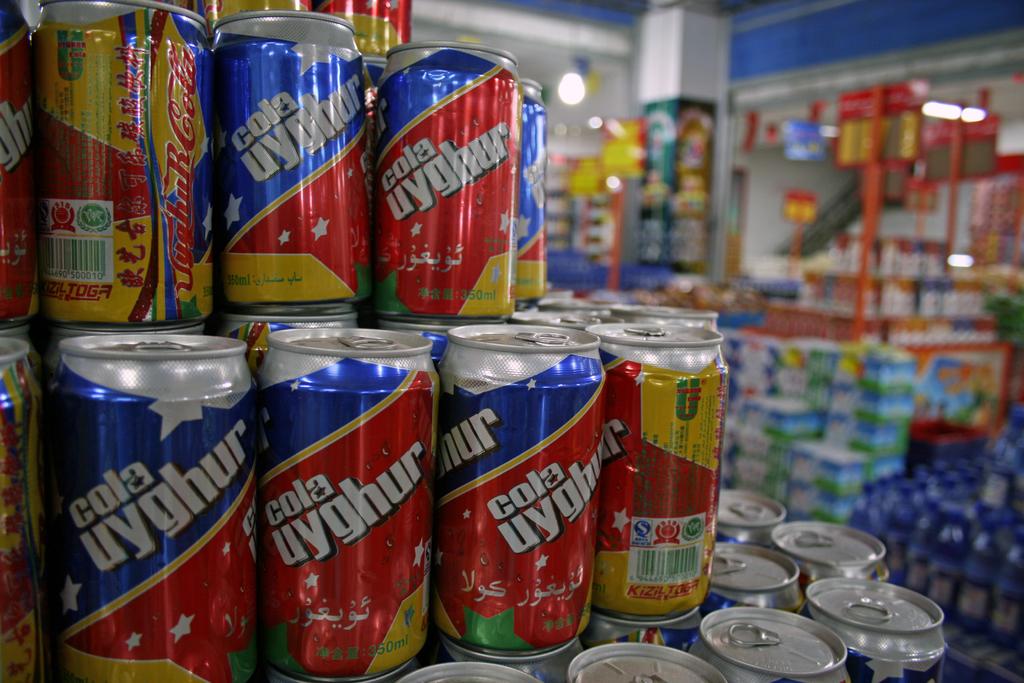What kind of cola is in the can?
Provide a succinct answer. Cola uyghur. What is the volume of the can?
Offer a very short reply. 350ml. 